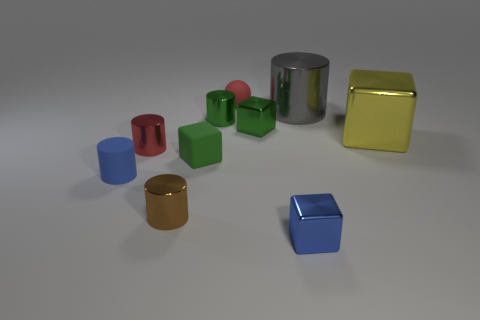Subtract all big cubes. How many cubes are left? 3 Subtract all green cylinders. How many cylinders are left? 4 Subtract 4 blocks. How many blocks are left? 0 Subtract 1 red spheres. How many objects are left? 9 Subtract all blocks. How many objects are left? 6 Subtract all blue blocks. Subtract all blue cylinders. How many blocks are left? 3 Subtract all red spheres. How many green cubes are left? 2 Subtract all tiny blue metal spheres. Subtract all gray metallic cylinders. How many objects are left? 9 Add 6 brown things. How many brown things are left? 7 Add 6 large brown shiny cylinders. How many large brown shiny cylinders exist? 6 